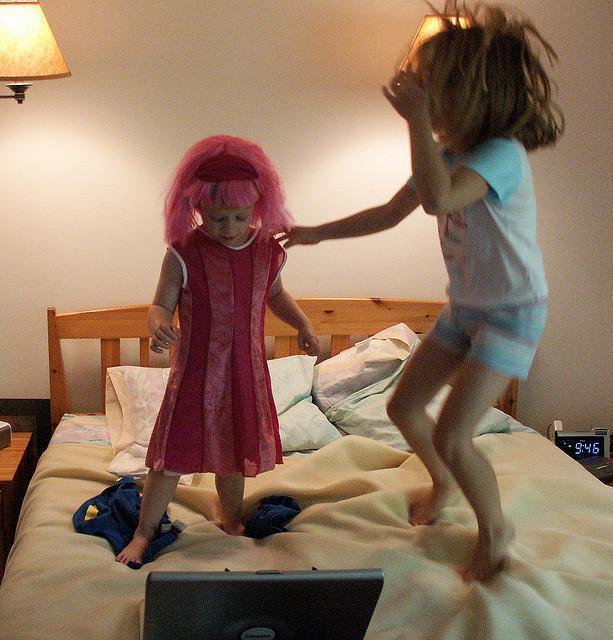How many pillowcases are there?
Give a very brief answer. 2. How many people are in the photo?
Give a very brief answer. 2. 